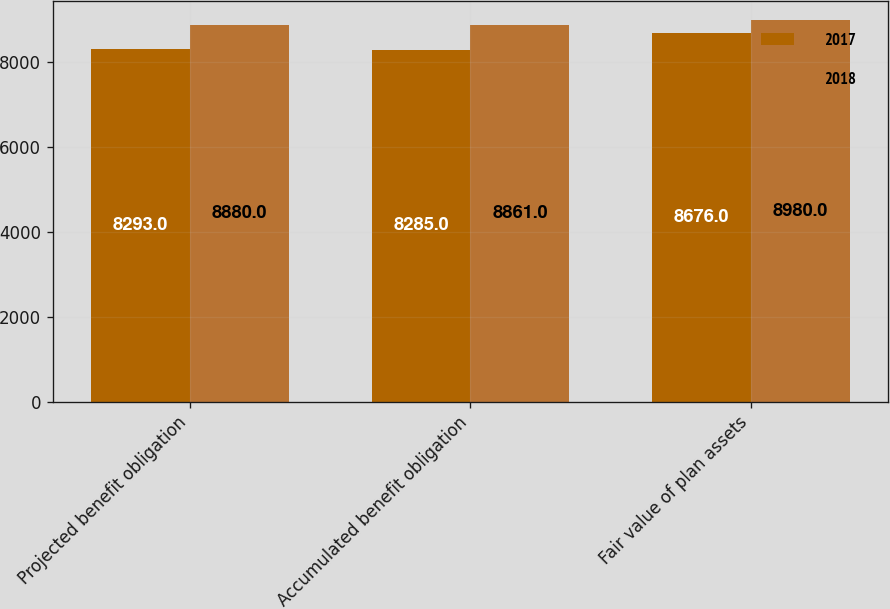<chart> <loc_0><loc_0><loc_500><loc_500><stacked_bar_chart><ecel><fcel>Projected benefit obligation<fcel>Accumulated benefit obligation<fcel>Fair value of plan assets<nl><fcel>2017<fcel>8293<fcel>8285<fcel>8676<nl><fcel>2018<fcel>8880<fcel>8861<fcel>8980<nl></chart> 